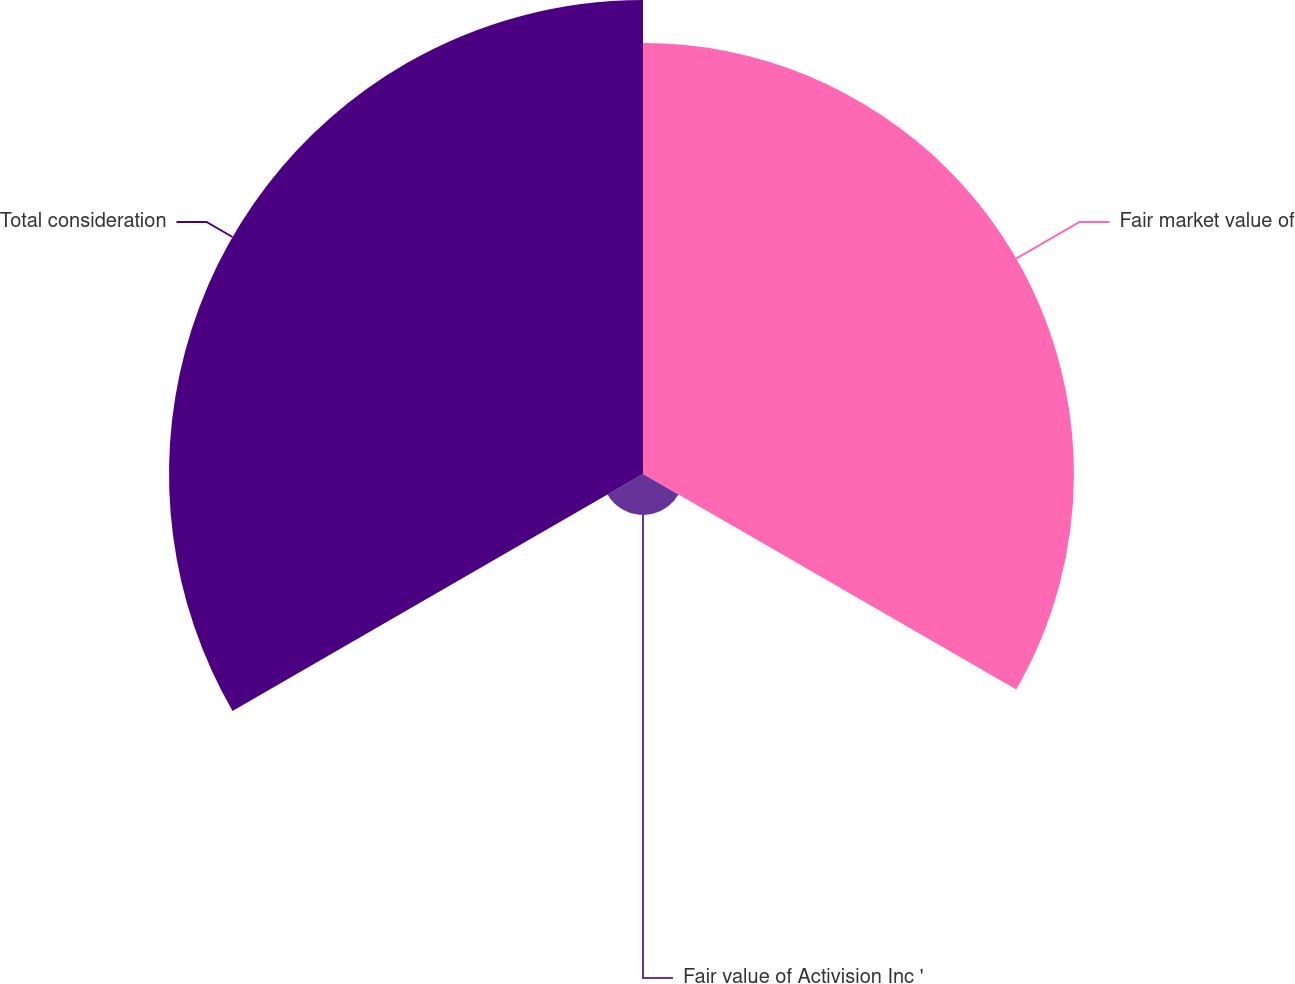Convert chart. <chart><loc_0><loc_0><loc_500><loc_500><pie_chart><fcel>Fair market value of<fcel>Fair value of Activision Inc '<fcel>Total consideration<nl><fcel>45.56%<fcel>4.33%<fcel>50.11%<nl></chart> 